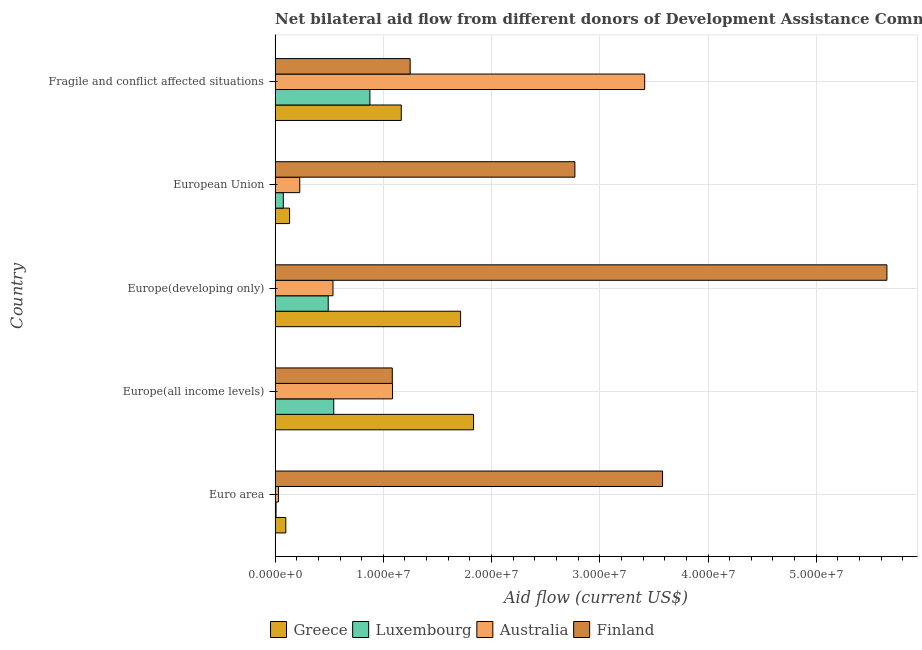Are the number of bars per tick equal to the number of legend labels?
Provide a short and direct response. Yes. What is the amount of aid given by luxembourg in Fragile and conflict affected situations?
Your answer should be very brief. 8.76e+06. Across all countries, what is the maximum amount of aid given by finland?
Make the answer very short. 5.65e+07. Across all countries, what is the minimum amount of aid given by greece?
Your response must be concise. 9.90e+05. In which country was the amount of aid given by luxembourg maximum?
Provide a short and direct response. Fragile and conflict affected situations. In which country was the amount of aid given by finland minimum?
Keep it short and to the point. Europe(all income levels). What is the total amount of aid given by australia in the graph?
Provide a succinct answer. 5.29e+07. What is the difference between the amount of aid given by greece in Europe(developing only) and that in European Union?
Your response must be concise. 1.58e+07. What is the difference between the amount of aid given by finland in Europe(all income levels) and the amount of aid given by greece in Fragile and conflict affected situations?
Provide a succinct answer. -8.30e+05. What is the average amount of aid given by finland per country?
Provide a succinct answer. 2.87e+07. What is the difference between the amount of aid given by greece and amount of aid given by finland in Fragile and conflict affected situations?
Make the answer very short. -8.20e+05. In how many countries, is the amount of aid given by australia greater than 16000000 US$?
Your answer should be very brief. 1. What is the ratio of the amount of aid given by luxembourg in Europe(all income levels) to that in Europe(developing only)?
Your answer should be very brief. 1.1. What is the difference between the highest and the second highest amount of aid given by finland?
Offer a very short reply. 2.07e+07. What is the difference between the highest and the lowest amount of aid given by finland?
Make the answer very short. 4.57e+07. Is the sum of the amount of aid given by luxembourg in Euro area and Europe(all income levels) greater than the maximum amount of aid given by greece across all countries?
Offer a terse response. No. Is it the case that in every country, the sum of the amount of aid given by greece and amount of aid given by luxembourg is greater than the sum of amount of aid given by finland and amount of aid given by australia?
Offer a terse response. No. What does the 1st bar from the top in Euro area represents?
Give a very brief answer. Finland. Is it the case that in every country, the sum of the amount of aid given by greece and amount of aid given by luxembourg is greater than the amount of aid given by australia?
Your answer should be compact. No. How many countries are there in the graph?
Offer a very short reply. 5. What is the difference between two consecutive major ticks on the X-axis?
Provide a short and direct response. 1.00e+07. Are the values on the major ticks of X-axis written in scientific E-notation?
Ensure brevity in your answer.  Yes. Does the graph contain any zero values?
Provide a short and direct response. No. Does the graph contain grids?
Provide a succinct answer. Yes. Where does the legend appear in the graph?
Ensure brevity in your answer.  Bottom center. How are the legend labels stacked?
Provide a succinct answer. Horizontal. What is the title of the graph?
Keep it short and to the point. Net bilateral aid flow from different donors of Development Assistance Committee in the year 1996. What is the Aid flow (current US$) in Greece in Euro area?
Ensure brevity in your answer.  9.90e+05. What is the Aid flow (current US$) in Australia in Euro area?
Keep it short and to the point. 3.10e+05. What is the Aid flow (current US$) of Finland in Euro area?
Your response must be concise. 3.58e+07. What is the Aid flow (current US$) in Greece in Europe(all income levels)?
Ensure brevity in your answer.  1.83e+07. What is the Aid flow (current US$) of Luxembourg in Europe(all income levels)?
Provide a short and direct response. 5.42e+06. What is the Aid flow (current US$) in Australia in Europe(all income levels)?
Give a very brief answer. 1.08e+07. What is the Aid flow (current US$) in Finland in Europe(all income levels)?
Your answer should be compact. 1.08e+07. What is the Aid flow (current US$) in Greece in Europe(developing only)?
Make the answer very short. 1.71e+07. What is the Aid flow (current US$) of Luxembourg in Europe(developing only)?
Provide a short and direct response. 4.91e+06. What is the Aid flow (current US$) in Australia in Europe(developing only)?
Your answer should be compact. 5.35e+06. What is the Aid flow (current US$) in Finland in Europe(developing only)?
Offer a very short reply. 5.65e+07. What is the Aid flow (current US$) in Greece in European Union?
Your answer should be compact. 1.34e+06. What is the Aid flow (current US$) of Luxembourg in European Union?
Make the answer very short. 7.60e+05. What is the Aid flow (current US$) in Australia in European Union?
Offer a terse response. 2.28e+06. What is the Aid flow (current US$) in Finland in European Union?
Keep it short and to the point. 2.77e+07. What is the Aid flow (current US$) of Greece in Fragile and conflict affected situations?
Give a very brief answer. 1.17e+07. What is the Aid flow (current US$) in Luxembourg in Fragile and conflict affected situations?
Provide a succinct answer. 8.76e+06. What is the Aid flow (current US$) of Australia in Fragile and conflict affected situations?
Provide a short and direct response. 3.42e+07. What is the Aid flow (current US$) of Finland in Fragile and conflict affected situations?
Your answer should be compact. 1.25e+07. Across all countries, what is the maximum Aid flow (current US$) in Greece?
Keep it short and to the point. 1.83e+07. Across all countries, what is the maximum Aid flow (current US$) in Luxembourg?
Provide a succinct answer. 8.76e+06. Across all countries, what is the maximum Aid flow (current US$) of Australia?
Your answer should be compact. 3.42e+07. Across all countries, what is the maximum Aid flow (current US$) in Finland?
Your response must be concise. 5.65e+07. Across all countries, what is the minimum Aid flow (current US$) of Greece?
Offer a terse response. 9.90e+05. Across all countries, what is the minimum Aid flow (current US$) in Luxembourg?
Provide a short and direct response. 9.00e+04. Across all countries, what is the minimum Aid flow (current US$) in Australia?
Your answer should be compact. 3.10e+05. Across all countries, what is the minimum Aid flow (current US$) of Finland?
Offer a very short reply. 1.08e+07. What is the total Aid flow (current US$) in Greece in the graph?
Give a very brief answer. 4.95e+07. What is the total Aid flow (current US$) in Luxembourg in the graph?
Provide a succinct answer. 1.99e+07. What is the total Aid flow (current US$) of Australia in the graph?
Give a very brief answer. 5.29e+07. What is the total Aid flow (current US$) in Finland in the graph?
Provide a succinct answer. 1.43e+08. What is the difference between the Aid flow (current US$) of Greece in Euro area and that in Europe(all income levels)?
Provide a succinct answer. -1.74e+07. What is the difference between the Aid flow (current US$) in Luxembourg in Euro area and that in Europe(all income levels)?
Give a very brief answer. -5.33e+06. What is the difference between the Aid flow (current US$) of Australia in Euro area and that in Europe(all income levels)?
Provide a succinct answer. -1.05e+07. What is the difference between the Aid flow (current US$) in Finland in Euro area and that in Europe(all income levels)?
Your response must be concise. 2.50e+07. What is the difference between the Aid flow (current US$) of Greece in Euro area and that in Europe(developing only)?
Make the answer very short. -1.62e+07. What is the difference between the Aid flow (current US$) in Luxembourg in Euro area and that in Europe(developing only)?
Ensure brevity in your answer.  -4.82e+06. What is the difference between the Aid flow (current US$) in Australia in Euro area and that in Europe(developing only)?
Provide a succinct answer. -5.04e+06. What is the difference between the Aid flow (current US$) in Finland in Euro area and that in Europe(developing only)?
Provide a succinct answer. -2.07e+07. What is the difference between the Aid flow (current US$) in Greece in Euro area and that in European Union?
Your answer should be very brief. -3.50e+05. What is the difference between the Aid flow (current US$) of Luxembourg in Euro area and that in European Union?
Ensure brevity in your answer.  -6.70e+05. What is the difference between the Aid flow (current US$) of Australia in Euro area and that in European Union?
Offer a terse response. -1.97e+06. What is the difference between the Aid flow (current US$) of Finland in Euro area and that in European Union?
Offer a very short reply. 8.10e+06. What is the difference between the Aid flow (current US$) in Greece in Euro area and that in Fragile and conflict affected situations?
Your answer should be very brief. -1.07e+07. What is the difference between the Aid flow (current US$) of Luxembourg in Euro area and that in Fragile and conflict affected situations?
Give a very brief answer. -8.67e+06. What is the difference between the Aid flow (current US$) in Australia in Euro area and that in Fragile and conflict affected situations?
Make the answer very short. -3.38e+07. What is the difference between the Aid flow (current US$) in Finland in Euro area and that in Fragile and conflict affected situations?
Offer a terse response. 2.33e+07. What is the difference between the Aid flow (current US$) in Greece in Europe(all income levels) and that in Europe(developing only)?
Keep it short and to the point. 1.20e+06. What is the difference between the Aid flow (current US$) of Luxembourg in Europe(all income levels) and that in Europe(developing only)?
Give a very brief answer. 5.10e+05. What is the difference between the Aid flow (current US$) of Australia in Europe(all income levels) and that in Europe(developing only)?
Your answer should be compact. 5.50e+06. What is the difference between the Aid flow (current US$) of Finland in Europe(all income levels) and that in Europe(developing only)?
Ensure brevity in your answer.  -4.57e+07. What is the difference between the Aid flow (current US$) of Greece in Europe(all income levels) and that in European Union?
Keep it short and to the point. 1.70e+07. What is the difference between the Aid flow (current US$) of Luxembourg in Europe(all income levels) and that in European Union?
Provide a short and direct response. 4.66e+06. What is the difference between the Aid flow (current US$) of Australia in Europe(all income levels) and that in European Union?
Give a very brief answer. 8.57e+06. What is the difference between the Aid flow (current US$) of Finland in Europe(all income levels) and that in European Union?
Ensure brevity in your answer.  -1.69e+07. What is the difference between the Aid flow (current US$) in Greece in Europe(all income levels) and that in Fragile and conflict affected situations?
Offer a terse response. 6.68e+06. What is the difference between the Aid flow (current US$) in Luxembourg in Europe(all income levels) and that in Fragile and conflict affected situations?
Ensure brevity in your answer.  -3.34e+06. What is the difference between the Aid flow (current US$) of Australia in Europe(all income levels) and that in Fragile and conflict affected situations?
Ensure brevity in your answer.  -2.33e+07. What is the difference between the Aid flow (current US$) in Finland in Europe(all income levels) and that in Fragile and conflict affected situations?
Your answer should be very brief. -1.65e+06. What is the difference between the Aid flow (current US$) in Greece in Europe(developing only) and that in European Union?
Give a very brief answer. 1.58e+07. What is the difference between the Aid flow (current US$) in Luxembourg in Europe(developing only) and that in European Union?
Offer a terse response. 4.15e+06. What is the difference between the Aid flow (current US$) of Australia in Europe(developing only) and that in European Union?
Offer a very short reply. 3.07e+06. What is the difference between the Aid flow (current US$) of Finland in Europe(developing only) and that in European Union?
Give a very brief answer. 2.88e+07. What is the difference between the Aid flow (current US$) in Greece in Europe(developing only) and that in Fragile and conflict affected situations?
Ensure brevity in your answer.  5.48e+06. What is the difference between the Aid flow (current US$) of Luxembourg in Europe(developing only) and that in Fragile and conflict affected situations?
Provide a short and direct response. -3.85e+06. What is the difference between the Aid flow (current US$) in Australia in Europe(developing only) and that in Fragile and conflict affected situations?
Keep it short and to the point. -2.88e+07. What is the difference between the Aid flow (current US$) of Finland in Europe(developing only) and that in Fragile and conflict affected situations?
Your answer should be very brief. 4.40e+07. What is the difference between the Aid flow (current US$) in Greece in European Union and that in Fragile and conflict affected situations?
Provide a succinct answer. -1.03e+07. What is the difference between the Aid flow (current US$) of Luxembourg in European Union and that in Fragile and conflict affected situations?
Keep it short and to the point. -8.00e+06. What is the difference between the Aid flow (current US$) in Australia in European Union and that in Fragile and conflict affected situations?
Provide a short and direct response. -3.19e+07. What is the difference between the Aid flow (current US$) in Finland in European Union and that in Fragile and conflict affected situations?
Provide a succinct answer. 1.52e+07. What is the difference between the Aid flow (current US$) of Greece in Euro area and the Aid flow (current US$) of Luxembourg in Europe(all income levels)?
Provide a succinct answer. -4.43e+06. What is the difference between the Aid flow (current US$) of Greece in Euro area and the Aid flow (current US$) of Australia in Europe(all income levels)?
Keep it short and to the point. -9.86e+06. What is the difference between the Aid flow (current US$) in Greece in Euro area and the Aid flow (current US$) in Finland in Europe(all income levels)?
Ensure brevity in your answer.  -9.84e+06. What is the difference between the Aid flow (current US$) of Luxembourg in Euro area and the Aid flow (current US$) of Australia in Europe(all income levels)?
Offer a terse response. -1.08e+07. What is the difference between the Aid flow (current US$) of Luxembourg in Euro area and the Aid flow (current US$) of Finland in Europe(all income levels)?
Give a very brief answer. -1.07e+07. What is the difference between the Aid flow (current US$) of Australia in Euro area and the Aid flow (current US$) of Finland in Europe(all income levels)?
Offer a terse response. -1.05e+07. What is the difference between the Aid flow (current US$) in Greece in Euro area and the Aid flow (current US$) in Luxembourg in Europe(developing only)?
Offer a terse response. -3.92e+06. What is the difference between the Aid flow (current US$) of Greece in Euro area and the Aid flow (current US$) of Australia in Europe(developing only)?
Give a very brief answer. -4.36e+06. What is the difference between the Aid flow (current US$) of Greece in Euro area and the Aid flow (current US$) of Finland in Europe(developing only)?
Ensure brevity in your answer.  -5.55e+07. What is the difference between the Aid flow (current US$) of Luxembourg in Euro area and the Aid flow (current US$) of Australia in Europe(developing only)?
Your answer should be very brief. -5.26e+06. What is the difference between the Aid flow (current US$) in Luxembourg in Euro area and the Aid flow (current US$) in Finland in Europe(developing only)?
Ensure brevity in your answer.  -5.64e+07. What is the difference between the Aid flow (current US$) in Australia in Euro area and the Aid flow (current US$) in Finland in Europe(developing only)?
Your response must be concise. -5.62e+07. What is the difference between the Aid flow (current US$) of Greece in Euro area and the Aid flow (current US$) of Australia in European Union?
Give a very brief answer. -1.29e+06. What is the difference between the Aid flow (current US$) of Greece in Euro area and the Aid flow (current US$) of Finland in European Union?
Provide a succinct answer. -2.67e+07. What is the difference between the Aid flow (current US$) in Luxembourg in Euro area and the Aid flow (current US$) in Australia in European Union?
Provide a short and direct response. -2.19e+06. What is the difference between the Aid flow (current US$) of Luxembourg in Euro area and the Aid flow (current US$) of Finland in European Union?
Ensure brevity in your answer.  -2.76e+07. What is the difference between the Aid flow (current US$) of Australia in Euro area and the Aid flow (current US$) of Finland in European Union?
Ensure brevity in your answer.  -2.74e+07. What is the difference between the Aid flow (current US$) of Greece in Euro area and the Aid flow (current US$) of Luxembourg in Fragile and conflict affected situations?
Your answer should be very brief. -7.77e+06. What is the difference between the Aid flow (current US$) of Greece in Euro area and the Aid flow (current US$) of Australia in Fragile and conflict affected situations?
Give a very brief answer. -3.32e+07. What is the difference between the Aid flow (current US$) in Greece in Euro area and the Aid flow (current US$) in Finland in Fragile and conflict affected situations?
Keep it short and to the point. -1.15e+07. What is the difference between the Aid flow (current US$) of Luxembourg in Euro area and the Aid flow (current US$) of Australia in Fragile and conflict affected situations?
Your answer should be very brief. -3.41e+07. What is the difference between the Aid flow (current US$) in Luxembourg in Euro area and the Aid flow (current US$) in Finland in Fragile and conflict affected situations?
Your response must be concise. -1.24e+07. What is the difference between the Aid flow (current US$) in Australia in Euro area and the Aid flow (current US$) in Finland in Fragile and conflict affected situations?
Offer a terse response. -1.22e+07. What is the difference between the Aid flow (current US$) in Greece in Europe(all income levels) and the Aid flow (current US$) in Luxembourg in Europe(developing only)?
Your response must be concise. 1.34e+07. What is the difference between the Aid flow (current US$) of Greece in Europe(all income levels) and the Aid flow (current US$) of Australia in Europe(developing only)?
Keep it short and to the point. 1.30e+07. What is the difference between the Aid flow (current US$) of Greece in Europe(all income levels) and the Aid flow (current US$) of Finland in Europe(developing only)?
Offer a terse response. -3.82e+07. What is the difference between the Aid flow (current US$) of Luxembourg in Europe(all income levels) and the Aid flow (current US$) of Finland in Europe(developing only)?
Keep it short and to the point. -5.11e+07. What is the difference between the Aid flow (current US$) in Australia in Europe(all income levels) and the Aid flow (current US$) in Finland in Europe(developing only)?
Ensure brevity in your answer.  -4.57e+07. What is the difference between the Aid flow (current US$) of Greece in Europe(all income levels) and the Aid flow (current US$) of Luxembourg in European Union?
Your answer should be very brief. 1.76e+07. What is the difference between the Aid flow (current US$) in Greece in Europe(all income levels) and the Aid flow (current US$) in Australia in European Union?
Provide a short and direct response. 1.61e+07. What is the difference between the Aid flow (current US$) in Greece in Europe(all income levels) and the Aid flow (current US$) in Finland in European Union?
Provide a short and direct response. -9.36e+06. What is the difference between the Aid flow (current US$) of Luxembourg in Europe(all income levels) and the Aid flow (current US$) of Australia in European Union?
Ensure brevity in your answer.  3.14e+06. What is the difference between the Aid flow (current US$) of Luxembourg in Europe(all income levels) and the Aid flow (current US$) of Finland in European Union?
Your answer should be very brief. -2.23e+07. What is the difference between the Aid flow (current US$) in Australia in Europe(all income levels) and the Aid flow (current US$) in Finland in European Union?
Ensure brevity in your answer.  -1.68e+07. What is the difference between the Aid flow (current US$) of Greece in Europe(all income levels) and the Aid flow (current US$) of Luxembourg in Fragile and conflict affected situations?
Keep it short and to the point. 9.58e+06. What is the difference between the Aid flow (current US$) in Greece in Europe(all income levels) and the Aid flow (current US$) in Australia in Fragile and conflict affected situations?
Provide a short and direct response. -1.58e+07. What is the difference between the Aid flow (current US$) of Greece in Europe(all income levels) and the Aid flow (current US$) of Finland in Fragile and conflict affected situations?
Offer a very short reply. 5.86e+06. What is the difference between the Aid flow (current US$) of Luxembourg in Europe(all income levels) and the Aid flow (current US$) of Australia in Fragile and conflict affected situations?
Make the answer very short. -2.87e+07. What is the difference between the Aid flow (current US$) in Luxembourg in Europe(all income levels) and the Aid flow (current US$) in Finland in Fragile and conflict affected situations?
Offer a very short reply. -7.06e+06. What is the difference between the Aid flow (current US$) in Australia in Europe(all income levels) and the Aid flow (current US$) in Finland in Fragile and conflict affected situations?
Your response must be concise. -1.63e+06. What is the difference between the Aid flow (current US$) of Greece in Europe(developing only) and the Aid flow (current US$) of Luxembourg in European Union?
Offer a very short reply. 1.64e+07. What is the difference between the Aid flow (current US$) of Greece in Europe(developing only) and the Aid flow (current US$) of Australia in European Union?
Keep it short and to the point. 1.49e+07. What is the difference between the Aid flow (current US$) of Greece in Europe(developing only) and the Aid flow (current US$) of Finland in European Union?
Ensure brevity in your answer.  -1.06e+07. What is the difference between the Aid flow (current US$) in Luxembourg in Europe(developing only) and the Aid flow (current US$) in Australia in European Union?
Your answer should be compact. 2.63e+06. What is the difference between the Aid flow (current US$) in Luxembourg in Europe(developing only) and the Aid flow (current US$) in Finland in European Union?
Your response must be concise. -2.28e+07. What is the difference between the Aid flow (current US$) in Australia in Europe(developing only) and the Aid flow (current US$) in Finland in European Union?
Your answer should be very brief. -2.24e+07. What is the difference between the Aid flow (current US$) in Greece in Europe(developing only) and the Aid flow (current US$) in Luxembourg in Fragile and conflict affected situations?
Ensure brevity in your answer.  8.38e+06. What is the difference between the Aid flow (current US$) of Greece in Europe(developing only) and the Aid flow (current US$) of Australia in Fragile and conflict affected situations?
Offer a very short reply. -1.70e+07. What is the difference between the Aid flow (current US$) of Greece in Europe(developing only) and the Aid flow (current US$) of Finland in Fragile and conflict affected situations?
Provide a short and direct response. 4.66e+06. What is the difference between the Aid flow (current US$) in Luxembourg in Europe(developing only) and the Aid flow (current US$) in Australia in Fragile and conflict affected situations?
Offer a terse response. -2.92e+07. What is the difference between the Aid flow (current US$) of Luxembourg in Europe(developing only) and the Aid flow (current US$) of Finland in Fragile and conflict affected situations?
Give a very brief answer. -7.57e+06. What is the difference between the Aid flow (current US$) in Australia in Europe(developing only) and the Aid flow (current US$) in Finland in Fragile and conflict affected situations?
Your response must be concise. -7.13e+06. What is the difference between the Aid flow (current US$) in Greece in European Union and the Aid flow (current US$) in Luxembourg in Fragile and conflict affected situations?
Provide a succinct answer. -7.42e+06. What is the difference between the Aid flow (current US$) of Greece in European Union and the Aid flow (current US$) of Australia in Fragile and conflict affected situations?
Provide a succinct answer. -3.28e+07. What is the difference between the Aid flow (current US$) of Greece in European Union and the Aid flow (current US$) of Finland in Fragile and conflict affected situations?
Keep it short and to the point. -1.11e+07. What is the difference between the Aid flow (current US$) in Luxembourg in European Union and the Aid flow (current US$) in Australia in Fragile and conflict affected situations?
Offer a very short reply. -3.34e+07. What is the difference between the Aid flow (current US$) of Luxembourg in European Union and the Aid flow (current US$) of Finland in Fragile and conflict affected situations?
Give a very brief answer. -1.17e+07. What is the difference between the Aid flow (current US$) of Australia in European Union and the Aid flow (current US$) of Finland in Fragile and conflict affected situations?
Offer a terse response. -1.02e+07. What is the average Aid flow (current US$) in Greece per country?
Keep it short and to the point. 9.89e+06. What is the average Aid flow (current US$) of Luxembourg per country?
Make the answer very short. 3.99e+06. What is the average Aid flow (current US$) of Australia per country?
Your answer should be compact. 1.06e+07. What is the average Aid flow (current US$) of Finland per country?
Ensure brevity in your answer.  2.87e+07. What is the difference between the Aid flow (current US$) in Greece and Aid flow (current US$) in Australia in Euro area?
Your response must be concise. 6.80e+05. What is the difference between the Aid flow (current US$) in Greece and Aid flow (current US$) in Finland in Euro area?
Offer a very short reply. -3.48e+07. What is the difference between the Aid flow (current US$) in Luxembourg and Aid flow (current US$) in Australia in Euro area?
Provide a short and direct response. -2.20e+05. What is the difference between the Aid flow (current US$) of Luxembourg and Aid flow (current US$) of Finland in Euro area?
Keep it short and to the point. -3.57e+07. What is the difference between the Aid flow (current US$) in Australia and Aid flow (current US$) in Finland in Euro area?
Make the answer very short. -3.55e+07. What is the difference between the Aid flow (current US$) of Greece and Aid flow (current US$) of Luxembourg in Europe(all income levels)?
Provide a succinct answer. 1.29e+07. What is the difference between the Aid flow (current US$) of Greece and Aid flow (current US$) of Australia in Europe(all income levels)?
Your answer should be compact. 7.49e+06. What is the difference between the Aid flow (current US$) in Greece and Aid flow (current US$) in Finland in Europe(all income levels)?
Offer a very short reply. 7.51e+06. What is the difference between the Aid flow (current US$) in Luxembourg and Aid flow (current US$) in Australia in Europe(all income levels)?
Your response must be concise. -5.43e+06. What is the difference between the Aid flow (current US$) in Luxembourg and Aid flow (current US$) in Finland in Europe(all income levels)?
Offer a very short reply. -5.41e+06. What is the difference between the Aid flow (current US$) of Australia and Aid flow (current US$) of Finland in Europe(all income levels)?
Your response must be concise. 2.00e+04. What is the difference between the Aid flow (current US$) of Greece and Aid flow (current US$) of Luxembourg in Europe(developing only)?
Offer a very short reply. 1.22e+07. What is the difference between the Aid flow (current US$) of Greece and Aid flow (current US$) of Australia in Europe(developing only)?
Give a very brief answer. 1.18e+07. What is the difference between the Aid flow (current US$) of Greece and Aid flow (current US$) of Finland in Europe(developing only)?
Offer a very short reply. -3.94e+07. What is the difference between the Aid flow (current US$) in Luxembourg and Aid flow (current US$) in Australia in Europe(developing only)?
Offer a terse response. -4.40e+05. What is the difference between the Aid flow (current US$) of Luxembourg and Aid flow (current US$) of Finland in Europe(developing only)?
Provide a succinct answer. -5.16e+07. What is the difference between the Aid flow (current US$) in Australia and Aid flow (current US$) in Finland in Europe(developing only)?
Offer a very short reply. -5.12e+07. What is the difference between the Aid flow (current US$) of Greece and Aid flow (current US$) of Luxembourg in European Union?
Provide a succinct answer. 5.80e+05. What is the difference between the Aid flow (current US$) in Greece and Aid flow (current US$) in Australia in European Union?
Your answer should be very brief. -9.40e+05. What is the difference between the Aid flow (current US$) in Greece and Aid flow (current US$) in Finland in European Union?
Offer a terse response. -2.64e+07. What is the difference between the Aid flow (current US$) of Luxembourg and Aid flow (current US$) of Australia in European Union?
Your answer should be compact. -1.52e+06. What is the difference between the Aid flow (current US$) in Luxembourg and Aid flow (current US$) in Finland in European Union?
Ensure brevity in your answer.  -2.69e+07. What is the difference between the Aid flow (current US$) in Australia and Aid flow (current US$) in Finland in European Union?
Give a very brief answer. -2.54e+07. What is the difference between the Aid flow (current US$) of Greece and Aid flow (current US$) of Luxembourg in Fragile and conflict affected situations?
Your answer should be very brief. 2.90e+06. What is the difference between the Aid flow (current US$) in Greece and Aid flow (current US$) in Australia in Fragile and conflict affected situations?
Your response must be concise. -2.25e+07. What is the difference between the Aid flow (current US$) of Greece and Aid flow (current US$) of Finland in Fragile and conflict affected situations?
Ensure brevity in your answer.  -8.20e+05. What is the difference between the Aid flow (current US$) in Luxembourg and Aid flow (current US$) in Australia in Fragile and conflict affected situations?
Ensure brevity in your answer.  -2.54e+07. What is the difference between the Aid flow (current US$) in Luxembourg and Aid flow (current US$) in Finland in Fragile and conflict affected situations?
Offer a very short reply. -3.72e+06. What is the difference between the Aid flow (current US$) of Australia and Aid flow (current US$) of Finland in Fragile and conflict affected situations?
Your response must be concise. 2.17e+07. What is the ratio of the Aid flow (current US$) in Greece in Euro area to that in Europe(all income levels)?
Make the answer very short. 0.05. What is the ratio of the Aid flow (current US$) of Luxembourg in Euro area to that in Europe(all income levels)?
Ensure brevity in your answer.  0.02. What is the ratio of the Aid flow (current US$) of Australia in Euro area to that in Europe(all income levels)?
Give a very brief answer. 0.03. What is the ratio of the Aid flow (current US$) in Finland in Euro area to that in Europe(all income levels)?
Your response must be concise. 3.31. What is the ratio of the Aid flow (current US$) of Greece in Euro area to that in Europe(developing only)?
Your answer should be compact. 0.06. What is the ratio of the Aid flow (current US$) in Luxembourg in Euro area to that in Europe(developing only)?
Offer a very short reply. 0.02. What is the ratio of the Aid flow (current US$) in Australia in Euro area to that in Europe(developing only)?
Ensure brevity in your answer.  0.06. What is the ratio of the Aid flow (current US$) in Finland in Euro area to that in Europe(developing only)?
Keep it short and to the point. 0.63. What is the ratio of the Aid flow (current US$) in Greece in Euro area to that in European Union?
Make the answer very short. 0.74. What is the ratio of the Aid flow (current US$) in Luxembourg in Euro area to that in European Union?
Provide a short and direct response. 0.12. What is the ratio of the Aid flow (current US$) in Australia in Euro area to that in European Union?
Provide a short and direct response. 0.14. What is the ratio of the Aid flow (current US$) of Finland in Euro area to that in European Union?
Your answer should be very brief. 1.29. What is the ratio of the Aid flow (current US$) of Greece in Euro area to that in Fragile and conflict affected situations?
Your response must be concise. 0.08. What is the ratio of the Aid flow (current US$) of Luxembourg in Euro area to that in Fragile and conflict affected situations?
Provide a short and direct response. 0.01. What is the ratio of the Aid flow (current US$) in Australia in Euro area to that in Fragile and conflict affected situations?
Your answer should be very brief. 0.01. What is the ratio of the Aid flow (current US$) of Finland in Euro area to that in Fragile and conflict affected situations?
Your response must be concise. 2.87. What is the ratio of the Aid flow (current US$) of Greece in Europe(all income levels) to that in Europe(developing only)?
Offer a terse response. 1.07. What is the ratio of the Aid flow (current US$) in Luxembourg in Europe(all income levels) to that in Europe(developing only)?
Your response must be concise. 1.1. What is the ratio of the Aid flow (current US$) in Australia in Europe(all income levels) to that in Europe(developing only)?
Provide a short and direct response. 2.03. What is the ratio of the Aid flow (current US$) of Finland in Europe(all income levels) to that in Europe(developing only)?
Give a very brief answer. 0.19. What is the ratio of the Aid flow (current US$) in Greece in Europe(all income levels) to that in European Union?
Give a very brief answer. 13.69. What is the ratio of the Aid flow (current US$) of Luxembourg in Europe(all income levels) to that in European Union?
Keep it short and to the point. 7.13. What is the ratio of the Aid flow (current US$) in Australia in Europe(all income levels) to that in European Union?
Make the answer very short. 4.76. What is the ratio of the Aid flow (current US$) in Finland in Europe(all income levels) to that in European Union?
Provide a short and direct response. 0.39. What is the ratio of the Aid flow (current US$) of Greece in Europe(all income levels) to that in Fragile and conflict affected situations?
Your answer should be very brief. 1.57. What is the ratio of the Aid flow (current US$) of Luxembourg in Europe(all income levels) to that in Fragile and conflict affected situations?
Your answer should be compact. 0.62. What is the ratio of the Aid flow (current US$) of Australia in Europe(all income levels) to that in Fragile and conflict affected situations?
Make the answer very short. 0.32. What is the ratio of the Aid flow (current US$) in Finland in Europe(all income levels) to that in Fragile and conflict affected situations?
Your answer should be compact. 0.87. What is the ratio of the Aid flow (current US$) of Greece in Europe(developing only) to that in European Union?
Offer a very short reply. 12.79. What is the ratio of the Aid flow (current US$) of Luxembourg in Europe(developing only) to that in European Union?
Your answer should be very brief. 6.46. What is the ratio of the Aid flow (current US$) in Australia in Europe(developing only) to that in European Union?
Give a very brief answer. 2.35. What is the ratio of the Aid flow (current US$) in Finland in Europe(developing only) to that in European Union?
Offer a terse response. 2.04. What is the ratio of the Aid flow (current US$) in Greece in Europe(developing only) to that in Fragile and conflict affected situations?
Offer a terse response. 1.47. What is the ratio of the Aid flow (current US$) of Luxembourg in Europe(developing only) to that in Fragile and conflict affected situations?
Ensure brevity in your answer.  0.56. What is the ratio of the Aid flow (current US$) in Australia in Europe(developing only) to that in Fragile and conflict affected situations?
Offer a very short reply. 0.16. What is the ratio of the Aid flow (current US$) of Finland in Europe(developing only) to that in Fragile and conflict affected situations?
Give a very brief answer. 4.53. What is the ratio of the Aid flow (current US$) in Greece in European Union to that in Fragile and conflict affected situations?
Offer a terse response. 0.11. What is the ratio of the Aid flow (current US$) in Luxembourg in European Union to that in Fragile and conflict affected situations?
Make the answer very short. 0.09. What is the ratio of the Aid flow (current US$) in Australia in European Union to that in Fragile and conflict affected situations?
Offer a very short reply. 0.07. What is the ratio of the Aid flow (current US$) in Finland in European Union to that in Fragile and conflict affected situations?
Provide a succinct answer. 2.22. What is the difference between the highest and the second highest Aid flow (current US$) in Greece?
Your answer should be compact. 1.20e+06. What is the difference between the highest and the second highest Aid flow (current US$) in Luxembourg?
Your answer should be compact. 3.34e+06. What is the difference between the highest and the second highest Aid flow (current US$) in Australia?
Give a very brief answer. 2.33e+07. What is the difference between the highest and the second highest Aid flow (current US$) in Finland?
Your response must be concise. 2.07e+07. What is the difference between the highest and the lowest Aid flow (current US$) of Greece?
Ensure brevity in your answer.  1.74e+07. What is the difference between the highest and the lowest Aid flow (current US$) in Luxembourg?
Provide a succinct answer. 8.67e+06. What is the difference between the highest and the lowest Aid flow (current US$) of Australia?
Keep it short and to the point. 3.38e+07. What is the difference between the highest and the lowest Aid flow (current US$) in Finland?
Provide a succinct answer. 4.57e+07. 